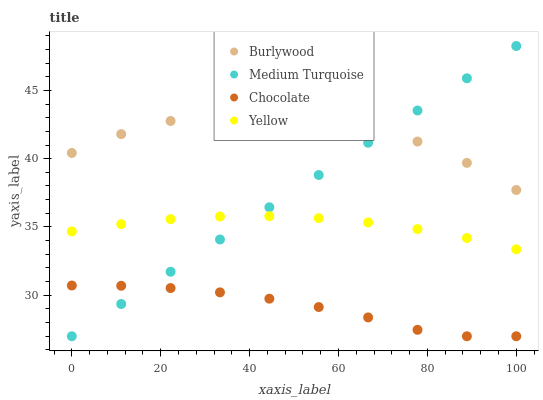Does Chocolate have the minimum area under the curve?
Answer yes or no. Yes. Does Burlywood have the maximum area under the curve?
Answer yes or no. Yes. Does Yellow have the minimum area under the curve?
Answer yes or no. No. Does Yellow have the maximum area under the curve?
Answer yes or no. No. Is Medium Turquoise the smoothest?
Answer yes or no. Yes. Is Burlywood the roughest?
Answer yes or no. Yes. Is Yellow the smoothest?
Answer yes or no. No. Is Yellow the roughest?
Answer yes or no. No. Does Medium Turquoise have the lowest value?
Answer yes or no. Yes. Does Yellow have the lowest value?
Answer yes or no. No. Does Medium Turquoise have the highest value?
Answer yes or no. Yes. Does Yellow have the highest value?
Answer yes or no. No. Is Yellow less than Burlywood?
Answer yes or no. Yes. Is Yellow greater than Chocolate?
Answer yes or no. Yes. Does Medium Turquoise intersect Chocolate?
Answer yes or no. Yes. Is Medium Turquoise less than Chocolate?
Answer yes or no. No. Is Medium Turquoise greater than Chocolate?
Answer yes or no. No. Does Yellow intersect Burlywood?
Answer yes or no. No. 